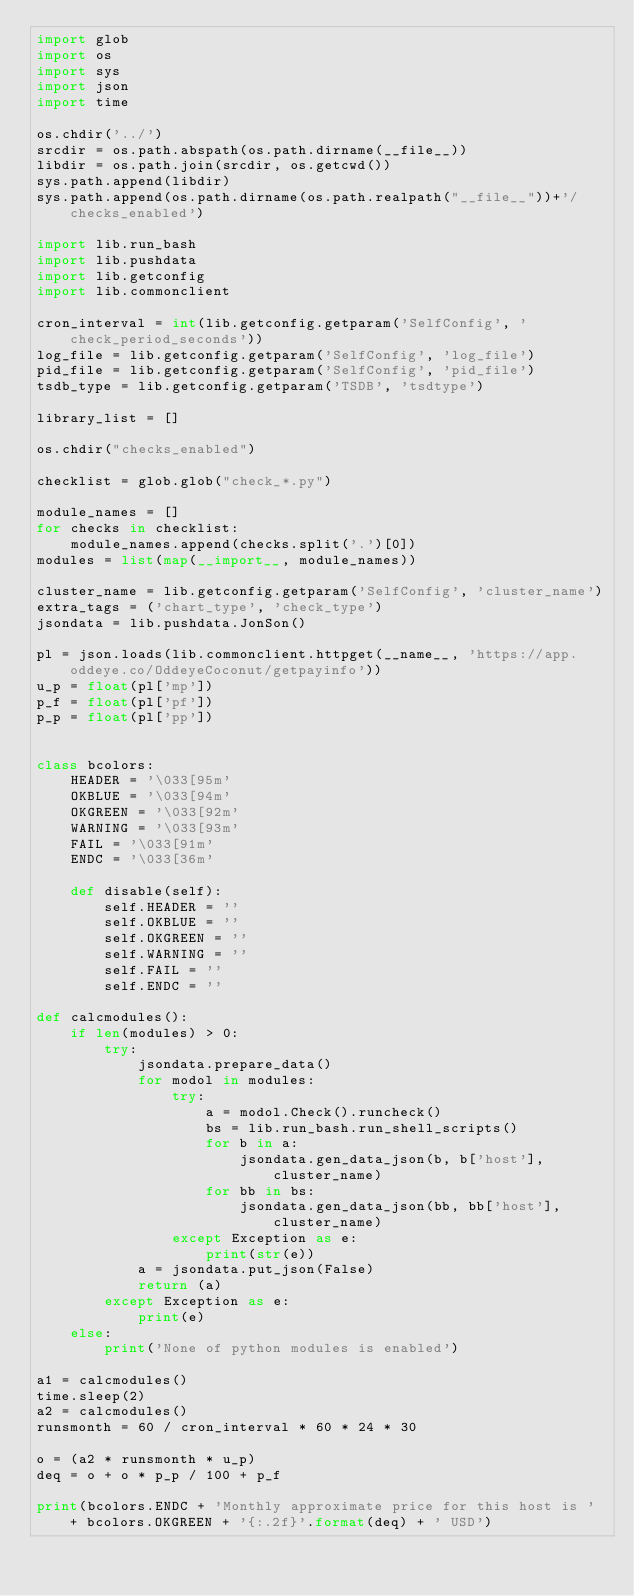<code> <loc_0><loc_0><loc_500><loc_500><_Python_>import glob
import os
import sys
import json
import time

os.chdir('../')
srcdir = os.path.abspath(os.path.dirname(__file__))
libdir = os.path.join(srcdir, os.getcwd())
sys.path.append(libdir)
sys.path.append(os.path.dirname(os.path.realpath("__file__"))+'/checks_enabled')

import lib.run_bash
import lib.pushdata
import lib.getconfig
import lib.commonclient

cron_interval = int(lib.getconfig.getparam('SelfConfig', 'check_period_seconds'))
log_file = lib.getconfig.getparam('SelfConfig', 'log_file')
pid_file = lib.getconfig.getparam('SelfConfig', 'pid_file')
tsdb_type = lib.getconfig.getparam('TSDB', 'tsdtype')

library_list = []

os.chdir("checks_enabled")

checklist = glob.glob("check_*.py")

module_names = []
for checks in checklist:
    module_names.append(checks.split('.')[0])
modules = list(map(__import__, module_names))

cluster_name = lib.getconfig.getparam('SelfConfig', 'cluster_name')
extra_tags = ('chart_type', 'check_type')
jsondata = lib.pushdata.JonSon()

pl = json.loads(lib.commonclient.httpget(__name__, 'https://app.oddeye.co/OddeyeCoconut/getpayinfo'))
u_p = float(pl['mp'])
p_f = float(pl['pf'])
p_p = float(pl['pp'])


class bcolors:
    HEADER = '\033[95m'
    OKBLUE = '\033[94m'
    OKGREEN = '\033[92m'
    WARNING = '\033[93m'
    FAIL = '\033[91m'
    ENDC = '\033[36m'

    def disable(self):
        self.HEADER = ''
        self.OKBLUE = ''
        self.OKGREEN = ''
        self.WARNING = ''
        self.FAIL = ''
        self.ENDC = ''

def calcmodules():
    if len(modules) > 0:
        try:
            jsondata.prepare_data()
            for modol in modules:
                try:
                    a = modol.Check().runcheck()
                    bs = lib.run_bash.run_shell_scripts()
                    for b in a:
                        jsondata.gen_data_json(b, b['host'], cluster_name)
                    for bb in bs:
                        jsondata.gen_data_json(bb, bb['host'], cluster_name)
                except Exception as e:
                    print(str(e))
            a = jsondata.put_json(False)
            return (a)
        except Exception as e:
            print(e)
    else:
        print('None of python modules is enabled')

a1 = calcmodules()
time.sleep(2)
a2 = calcmodules()
runsmonth = 60 / cron_interval * 60 * 24 * 30

o = (a2 * runsmonth * u_p)
deq = o + o * p_p / 100 + p_f

print(bcolors.ENDC + 'Monthly approximate price for this host is ' + bcolors.OKGREEN + '{:.2f}'.format(deq) + ' USD')

</code> 